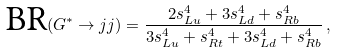Convert formula to latex. <formula><loc_0><loc_0><loc_500><loc_500>\text {BR} ( G ^ { * } \to j j ) = \frac { 2 s _ { L u } ^ { 4 } + 3 s _ { L d } ^ { 4 } + s _ { R b } ^ { 4 } } { 3 s _ { L u } ^ { 4 } + s _ { R t } ^ { 4 } + 3 s _ { L d } ^ { 4 } + s _ { R b } ^ { 4 } } \, ,</formula> 